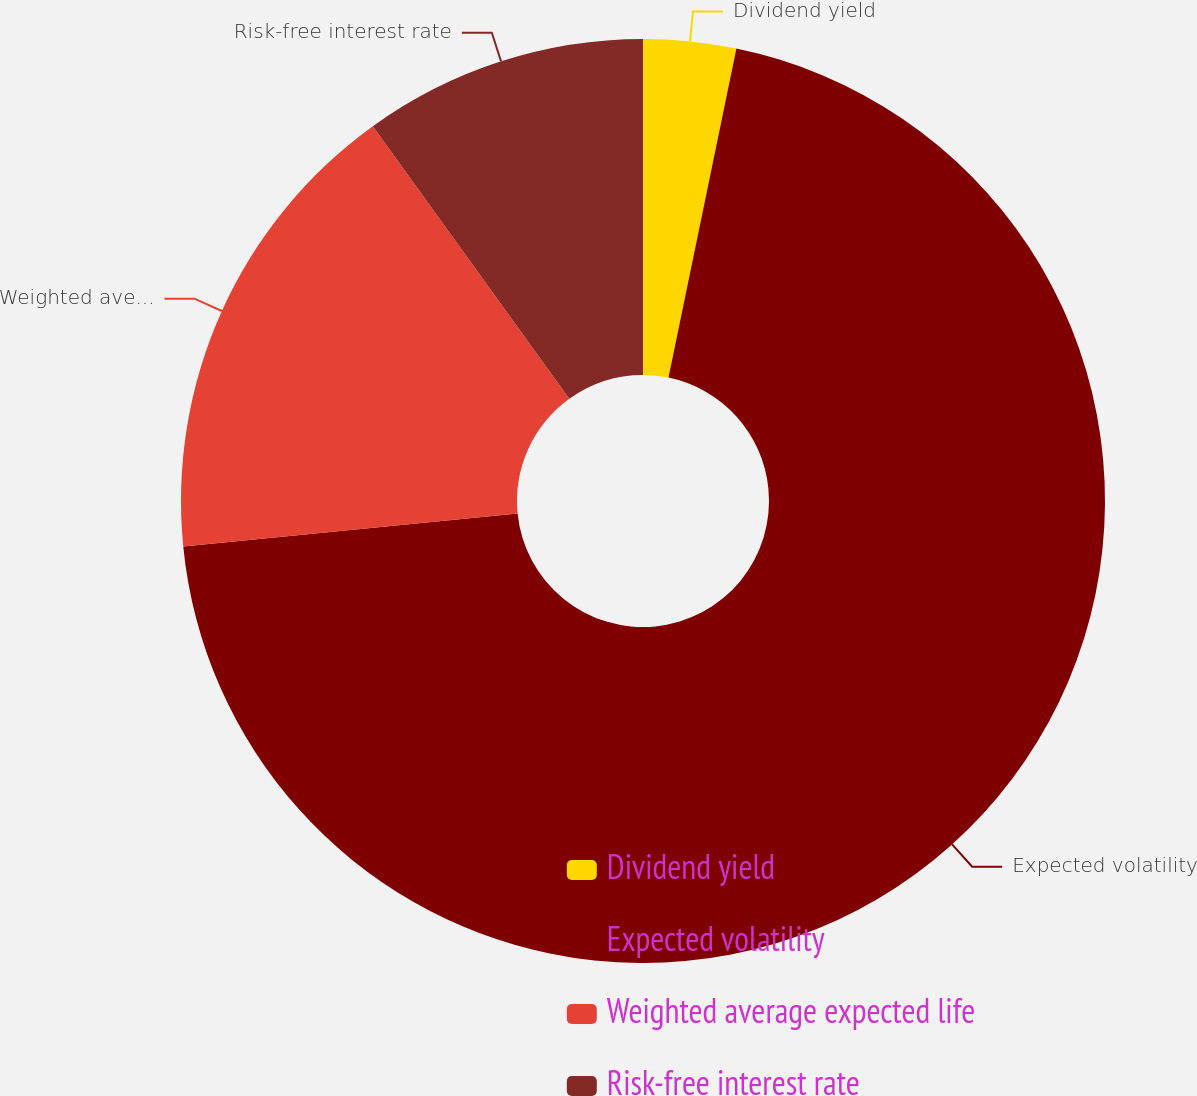Convert chart to OTSL. <chart><loc_0><loc_0><loc_500><loc_500><pie_chart><fcel>Dividend yield<fcel>Expected volatility<fcel>Weighted average expected life<fcel>Risk-free interest rate<nl><fcel>3.24%<fcel>70.19%<fcel>16.63%<fcel>9.94%<nl></chart> 